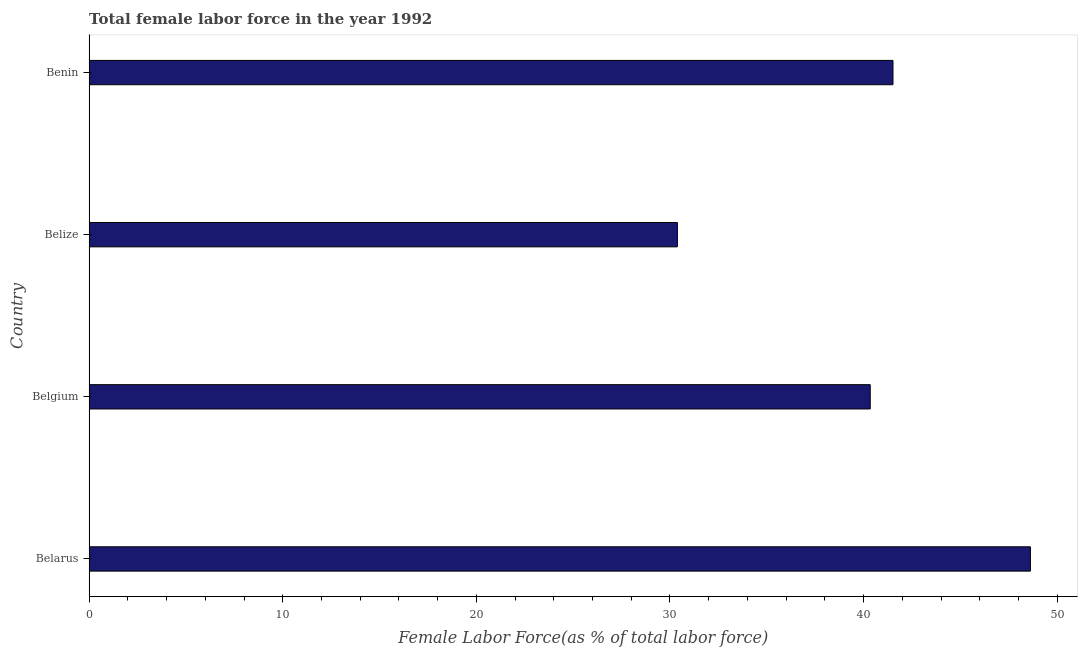What is the title of the graph?
Provide a short and direct response. Total female labor force in the year 1992. What is the label or title of the X-axis?
Provide a succinct answer. Female Labor Force(as % of total labor force). What is the total female labor force in Belarus?
Provide a short and direct response. 48.61. Across all countries, what is the maximum total female labor force?
Keep it short and to the point. 48.61. Across all countries, what is the minimum total female labor force?
Offer a very short reply. 30.38. In which country was the total female labor force maximum?
Your answer should be compact. Belarus. In which country was the total female labor force minimum?
Give a very brief answer. Belize. What is the sum of the total female labor force?
Your answer should be very brief. 160.86. What is the difference between the total female labor force in Belarus and Belize?
Ensure brevity in your answer.  18.23. What is the average total female labor force per country?
Offer a terse response. 40.21. What is the median total female labor force?
Provide a short and direct response. 40.93. In how many countries, is the total female labor force greater than 40 %?
Your response must be concise. 3. What is the ratio of the total female labor force in Belarus to that in Belgium?
Offer a very short reply. 1.21. What is the difference between the highest and the second highest total female labor force?
Your answer should be compact. 7.1. Is the sum of the total female labor force in Belgium and Benin greater than the maximum total female labor force across all countries?
Your answer should be very brief. Yes. What is the difference between the highest and the lowest total female labor force?
Make the answer very short. 18.23. In how many countries, is the total female labor force greater than the average total female labor force taken over all countries?
Keep it short and to the point. 3. How many bars are there?
Provide a succinct answer. 4. Are the values on the major ticks of X-axis written in scientific E-notation?
Your answer should be very brief. No. What is the Female Labor Force(as % of total labor force) in Belarus?
Your response must be concise. 48.61. What is the Female Labor Force(as % of total labor force) of Belgium?
Provide a short and direct response. 40.34. What is the Female Labor Force(as % of total labor force) in Belize?
Keep it short and to the point. 30.38. What is the Female Labor Force(as % of total labor force) of Benin?
Give a very brief answer. 41.52. What is the difference between the Female Labor Force(as % of total labor force) in Belarus and Belgium?
Your answer should be very brief. 8.27. What is the difference between the Female Labor Force(as % of total labor force) in Belarus and Belize?
Offer a very short reply. 18.23. What is the difference between the Female Labor Force(as % of total labor force) in Belarus and Benin?
Ensure brevity in your answer.  7.1. What is the difference between the Female Labor Force(as % of total labor force) in Belgium and Belize?
Your answer should be very brief. 9.96. What is the difference between the Female Labor Force(as % of total labor force) in Belgium and Benin?
Make the answer very short. -1.18. What is the difference between the Female Labor Force(as % of total labor force) in Belize and Benin?
Offer a terse response. -11.13. What is the ratio of the Female Labor Force(as % of total labor force) in Belarus to that in Belgium?
Give a very brief answer. 1.21. What is the ratio of the Female Labor Force(as % of total labor force) in Belarus to that in Benin?
Your response must be concise. 1.17. What is the ratio of the Female Labor Force(as % of total labor force) in Belgium to that in Belize?
Keep it short and to the point. 1.33. What is the ratio of the Female Labor Force(as % of total labor force) in Belgium to that in Benin?
Provide a succinct answer. 0.97. What is the ratio of the Female Labor Force(as % of total labor force) in Belize to that in Benin?
Your answer should be compact. 0.73. 